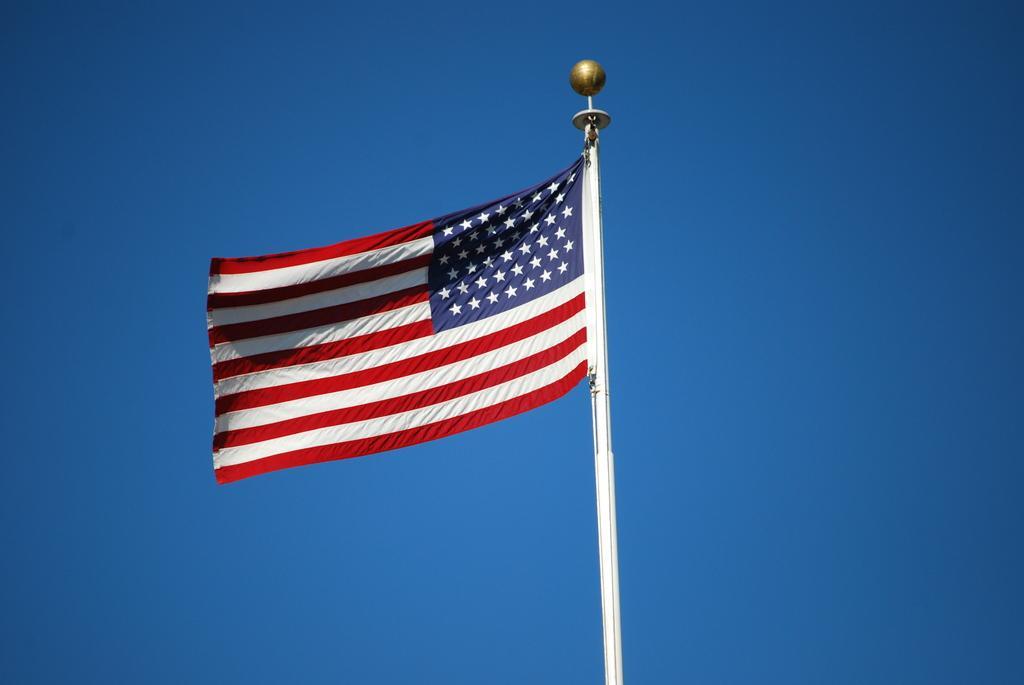Describe this image in one or two sentences. In this image there is a pole, there is a flag, at the background of the image there is the sky. 